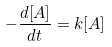Convert formula to latex. <formula><loc_0><loc_0><loc_500><loc_500>- \frac { d [ A ] } { d t } = k [ A ]</formula> 